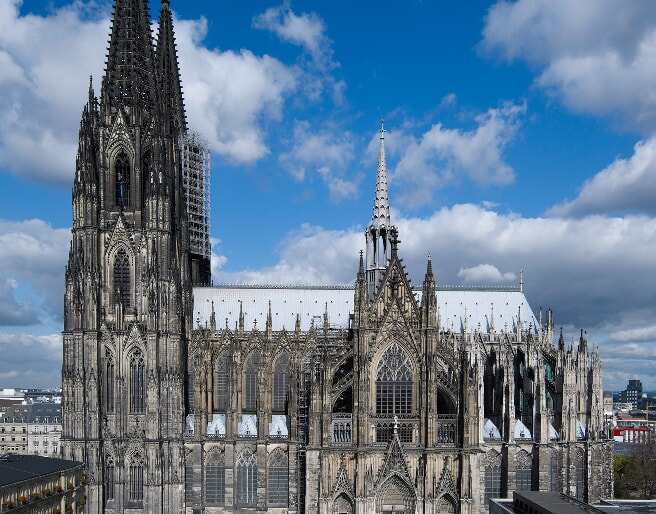Can you explain the architectural style of Cologne Cathedral? Certainly, the Cologne Cathedral is a sterling example of Gothic architecture, characterized by vertical lines and a lightweight frame structure, allowing for towering heights and spatious interiors. The architecture is renowned for its pointed arches, ribbed vaults, and flying buttresses, elements that not only enhance the aesthetic value but also distribute the structural weight more efficiently. The facade is adorned with a vast array of sculptures, and the interior is punctuated by stunning stained glass windows, adding a vibrant play of colors to the somber stone interiors. 